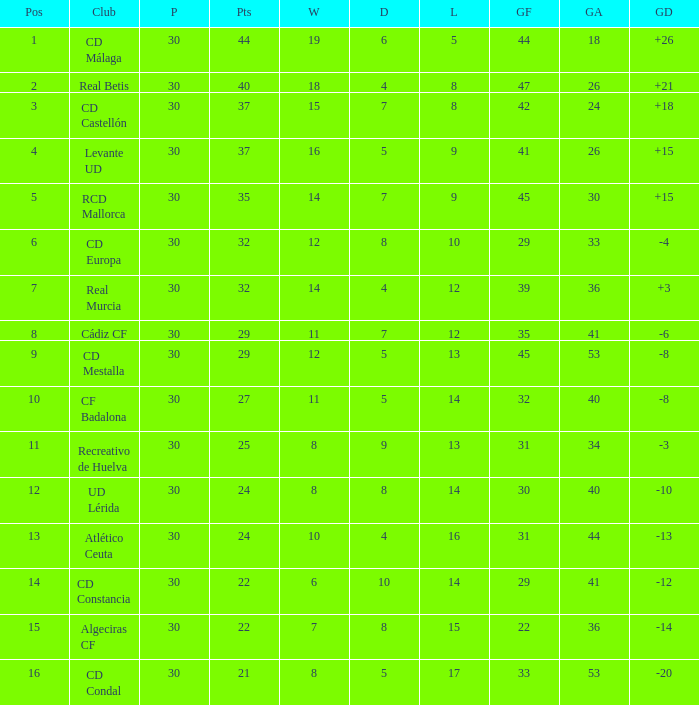What is the number of wins when the goals against is larger than 41, points is 29, and draws are larger than 5? 0.0. 